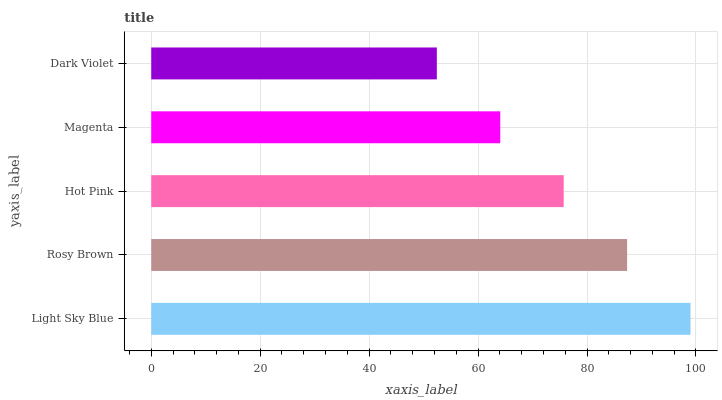Is Dark Violet the minimum?
Answer yes or no. Yes. Is Light Sky Blue the maximum?
Answer yes or no. Yes. Is Rosy Brown the minimum?
Answer yes or no. No. Is Rosy Brown the maximum?
Answer yes or no. No. Is Light Sky Blue greater than Rosy Brown?
Answer yes or no. Yes. Is Rosy Brown less than Light Sky Blue?
Answer yes or no. Yes. Is Rosy Brown greater than Light Sky Blue?
Answer yes or no. No. Is Light Sky Blue less than Rosy Brown?
Answer yes or no. No. Is Hot Pink the high median?
Answer yes or no. Yes. Is Hot Pink the low median?
Answer yes or no. Yes. Is Magenta the high median?
Answer yes or no. No. Is Light Sky Blue the low median?
Answer yes or no. No. 